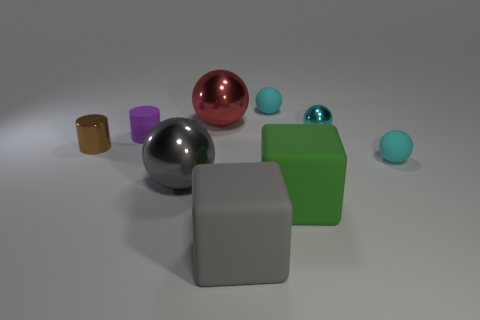Subtract all cyan spheres. How many were subtracted if there are1cyan spheres left? 2 Add 1 big brown cubes. How many objects exist? 10 Subtract all small cyan metallic balls. How many balls are left? 4 Subtract all blocks. How many objects are left? 7 Subtract 1 cylinders. How many cylinders are left? 1 Add 1 big purple cylinders. How many big purple cylinders exist? 1 Subtract all gray spheres. How many spheres are left? 4 Subtract 1 cyan balls. How many objects are left? 8 Subtract all gray balls. Subtract all gray cubes. How many balls are left? 4 Subtract all cyan blocks. How many brown cylinders are left? 1 